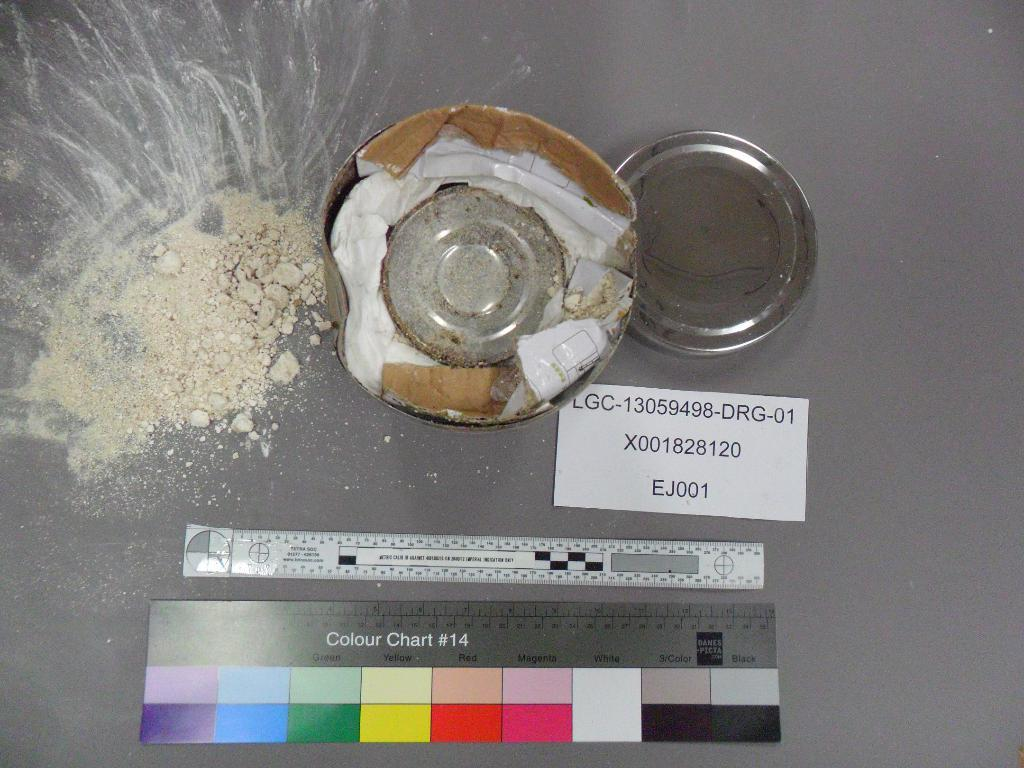<image>
Share a concise interpretation of the image provided. Several things on a table including a pile of sand, a color chart, a ruler and a note that has the number EJ001 on it. 